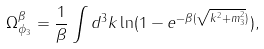Convert formula to latex. <formula><loc_0><loc_0><loc_500><loc_500>\Omega ^ { \beta } _ { \phi _ { 3 } } = \frac { 1 } { \beta } \int d ^ { 3 } k \ln ( 1 - e ^ { - \beta ( \sqrt { { k } ^ { 2 } + m ^ { 2 } _ { 3 } } ) } ) ,</formula> 